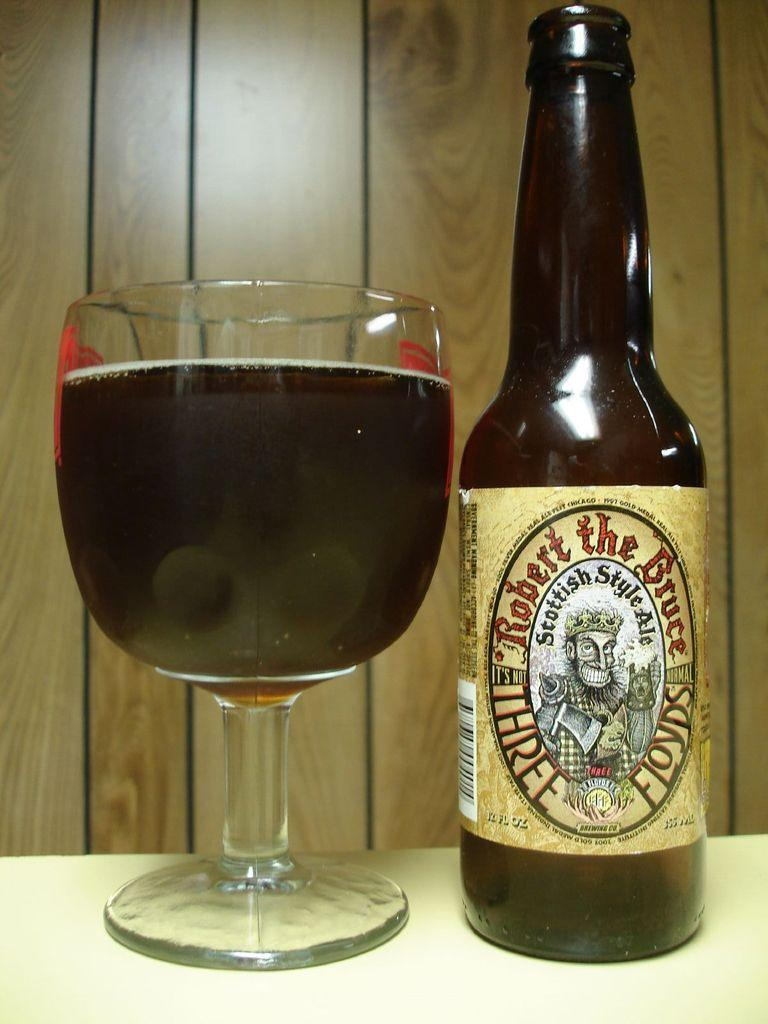Provide a one-sentence caption for the provided image. A glass and a bottle filled with Robert the Bruce Ale sitting on a table. 